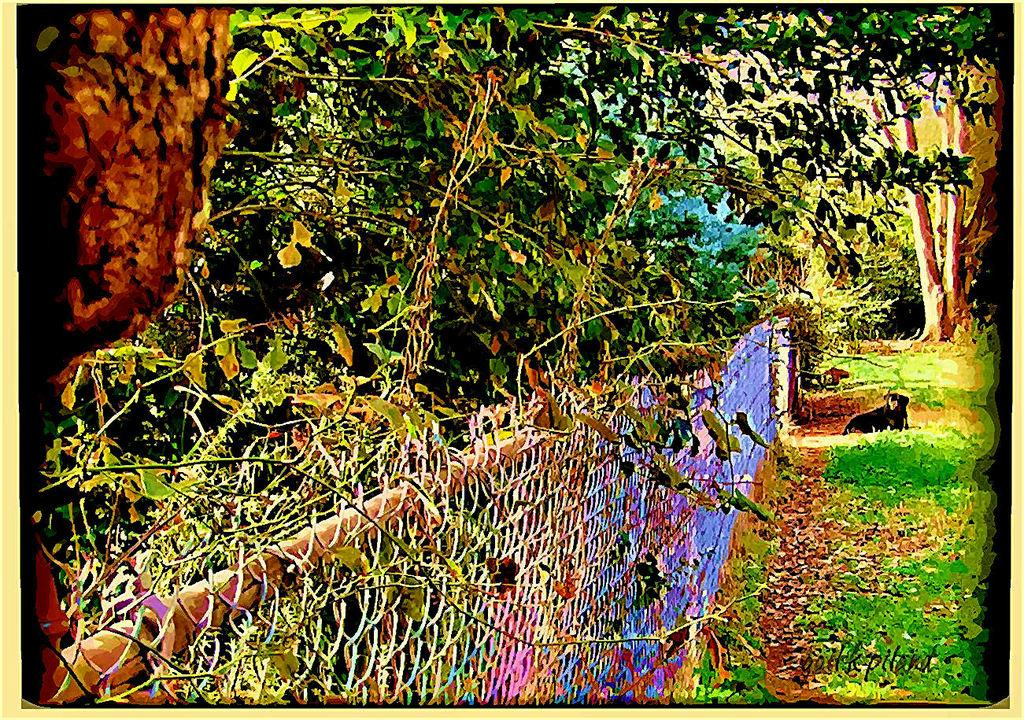What type of artwork is depicted in the image? The image appears to be a painting. What animal can be seen in the painting? There is a dog sitting on the grass in the painting. What is the dog sitting on? The dog is sitting on the grass. What type of structure is visible in the background of the painting? There is a fence visible in the image. What type of vegetation is present in the painting? There are trees with branches and leaves in the image. What type of health advice is the dog giving in the painting? The dog is not giving any health advice in the painting; it is simply sitting on the grass. What color is the orange that the dog is holding in the painting? There is no orange present in the painting; the dog is sitting on the grass and there are trees with branches and leaves in the image. 